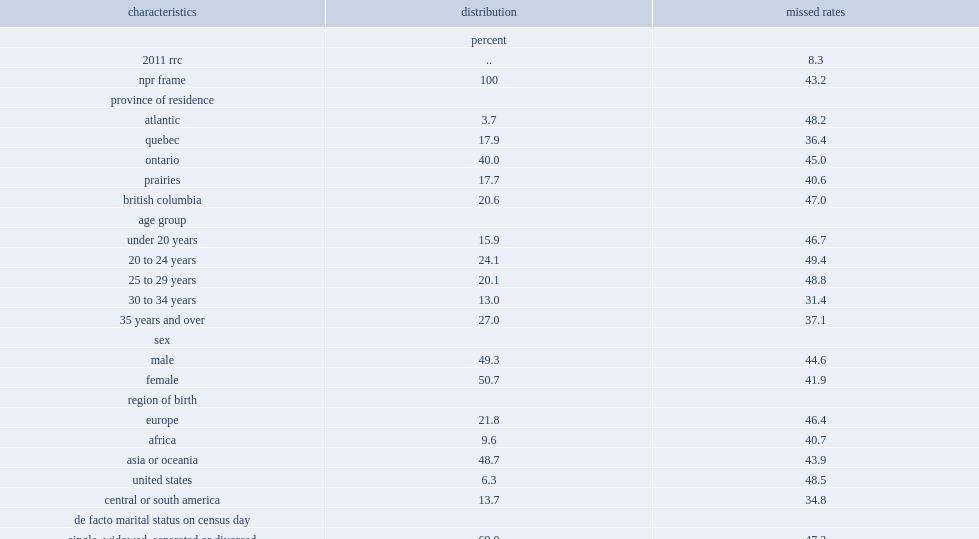What was the overall missed rate of nprs in 2011? 43.2. What percentage of nprs aged 20 to 24 were missed in the 2011 census? 49.4. What percentage of nprs 30 to 34 years were missed in the 2011 census? 31.4. What was the missed rate of nprs who were not in a couple? 47.3. What percentage is the missed rate of nprs who were not in a couple higher than that of nprs who were in a couple? 14.6. What percentage of nprs who were granted temporary residence in canada two or more years before census day were missed? 36.4. Who were less likely to be missed, refugee status claimants or nprs who held a work permit? Refugee status claimant. Parse the full table. {'header': ['characteristics', 'distribution', 'missed rates'], 'rows': [['', 'percent', ''], ['2011 rrc', '..', '8.3'], ['npr frame', '100', '43.2'], ['province of residence', '', ''], ['atlantic', '3.7', '48.2'], ['quebec', '17.9', '36.4'], ['ontario', '40.0', '45.0'], ['prairies', '17.7', '40.6'], ['british columbia', '20.6', '47.0'], ['age group', '', ''], ['under 20 years', '15.9', '46.7'], ['20 to 24 years', '24.1', '49.4'], ['25 to 29 years', '20.1', '48.8'], ['30 to 34 years', '13.0', '31.4'], ['35 years and over', '27.0', '37.1'], ['sex', '', ''], ['male', '49.3', '44.6'], ['female', '50.7', '41.9'], ['region of birth', '', ''], ['europe', '21.8', '46.4'], ['africa', '9.6', '40.7'], ['asia or oceania', '48.7', '43.9'], ['united states', '6.3', '48.5'], ['central or south america', '13.7', '34.8'], ['de facto marital status on census day', '', ''], ['single, widowed, separated or divorced', '69.0', '47.3'], ['married or common-law', '31.0', '32.7'], ['mother tongue on census day', '', ''], ['english', '21.7', '47.0'], ['french', '9.2', '37.0'], ['non-official language', '69.1', '42.8'], ['first npr permit', '', ''], ['no', '63.7', '41.7'], ['yes', '36.3', '46.0'], ['holds more than one permit', '', ''], ['no', '71.0', '45.0'], ['yes', '29.0', '39.1'], ['length of stay in canada', '', ''], ['0 to 6 months', '22.4', '53.1'], ['6 to 12 months', '20.1', '50.4'], ['12 to 24 months', '24.4', '38.0'], ['24 months or more', '33.0', '36.4'], ['type of permit', '', ''], ['refugee status claimant', '20.5', '31.5'], ['work permit', '52.4', '46.2'], ["study or minister's permit", '27.2', '46.5']]} 